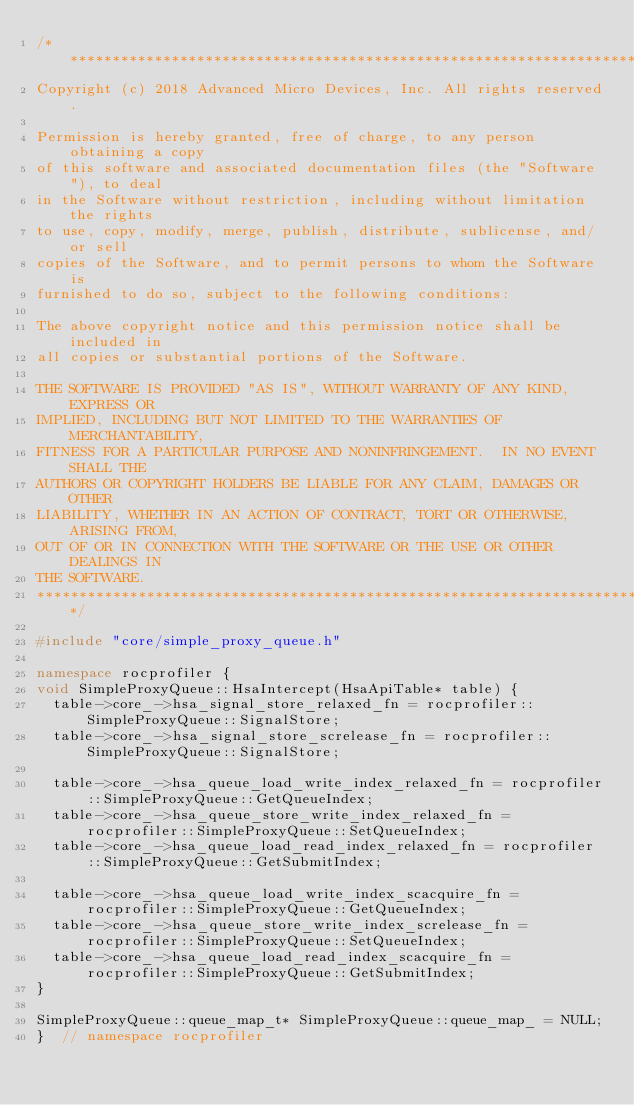<code> <loc_0><loc_0><loc_500><loc_500><_C++_>/******************************************************************************
Copyright (c) 2018 Advanced Micro Devices, Inc. All rights reserved.

Permission is hereby granted, free of charge, to any person obtaining a copy
of this software and associated documentation files (the "Software"), to deal
in the Software without restriction, including without limitation the rights
to use, copy, modify, merge, publish, distribute, sublicense, and/or sell
copies of the Software, and to permit persons to whom the Software is
furnished to do so, subject to the following conditions:

The above copyright notice and this permission notice shall be included in
all copies or substantial portions of the Software.

THE SOFTWARE IS PROVIDED "AS IS", WITHOUT WARRANTY OF ANY KIND, EXPRESS OR
IMPLIED, INCLUDING BUT NOT LIMITED TO THE WARRANTIES OF MERCHANTABILITY,
FITNESS FOR A PARTICULAR PURPOSE AND NONINFRINGEMENT.  IN NO EVENT SHALL THE
AUTHORS OR COPYRIGHT HOLDERS BE LIABLE FOR ANY CLAIM, DAMAGES OR OTHER
LIABILITY, WHETHER IN AN ACTION OF CONTRACT, TORT OR OTHERWISE, ARISING FROM,
OUT OF OR IN CONNECTION WITH THE SOFTWARE OR THE USE OR OTHER DEALINGS IN
THE SOFTWARE.
*******************************************************************************/

#include "core/simple_proxy_queue.h"

namespace rocprofiler {
void SimpleProxyQueue::HsaIntercept(HsaApiTable* table) {
  table->core_->hsa_signal_store_relaxed_fn = rocprofiler::SimpleProxyQueue::SignalStore;
  table->core_->hsa_signal_store_screlease_fn = rocprofiler::SimpleProxyQueue::SignalStore;

  table->core_->hsa_queue_load_write_index_relaxed_fn = rocprofiler::SimpleProxyQueue::GetQueueIndex;
  table->core_->hsa_queue_store_write_index_relaxed_fn = rocprofiler::SimpleProxyQueue::SetQueueIndex;
  table->core_->hsa_queue_load_read_index_relaxed_fn = rocprofiler::SimpleProxyQueue::GetSubmitIndex;

  table->core_->hsa_queue_load_write_index_scacquire_fn = rocprofiler::SimpleProxyQueue::GetQueueIndex;
  table->core_->hsa_queue_store_write_index_screlease_fn = rocprofiler::SimpleProxyQueue::SetQueueIndex;
  table->core_->hsa_queue_load_read_index_scacquire_fn = rocprofiler::SimpleProxyQueue::GetSubmitIndex;
}

SimpleProxyQueue::queue_map_t* SimpleProxyQueue::queue_map_ = NULL;
}  // namespace rocprofiler
</code> 